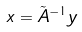<formula> <loc_0><loc_0><loc_500><loc_500>x = \tilde { A } ^ { - 1 } y</formula> 